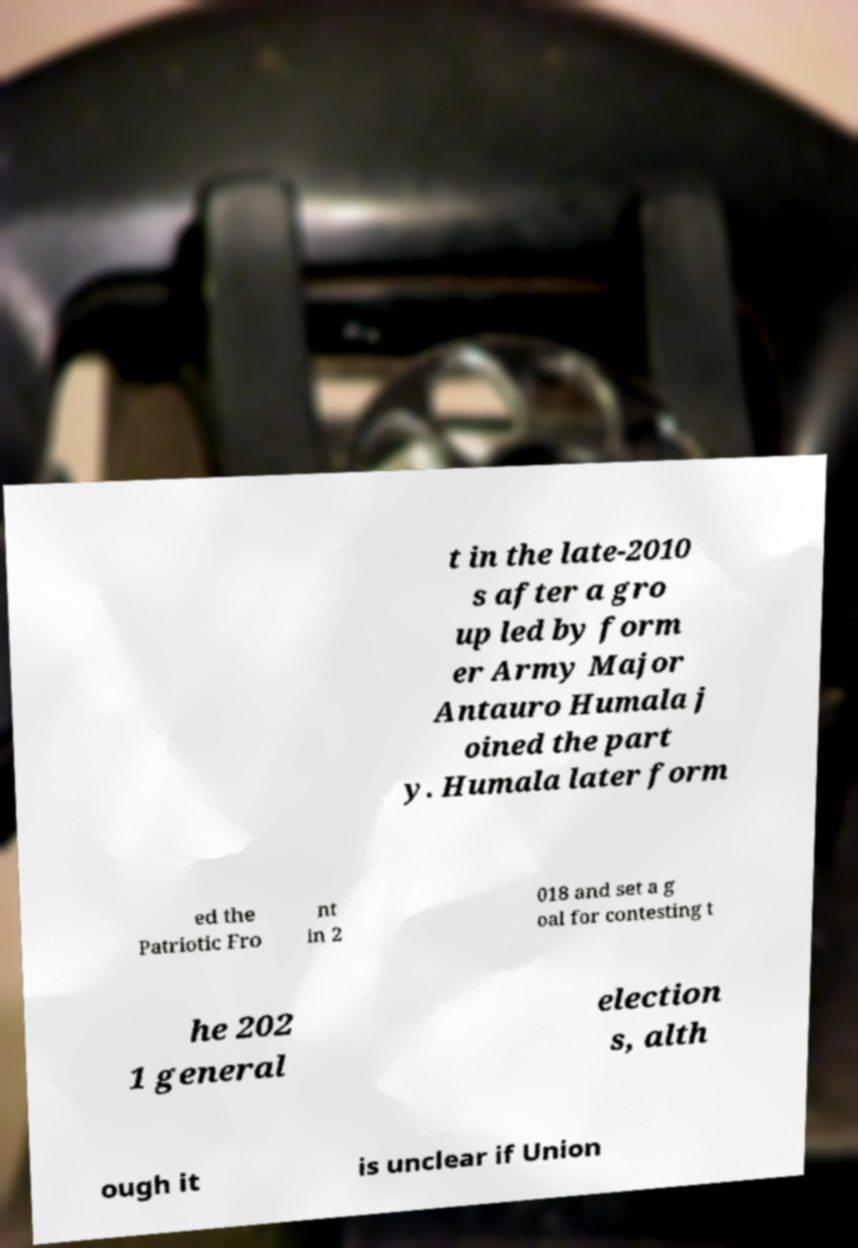What messages or text are displayed in this image? I need them in a readable, typed format. t in the late-2010 s after a gro up led by form er Army Major Antauro Humala j oined the part y. Humala later form ed the Patriotic Fro nt in 2 018 and set a g oal for contesting t he 202 1 general election s, alth ough it is unclear if Union 